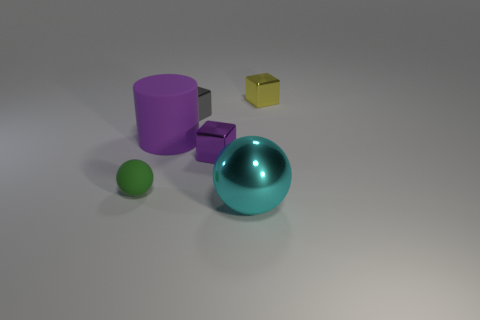Are there any other things that are the same shape as the big purple object?
Offer a terse response. No. What number of cylinders are green matte objects or metallic objects?
Keep it short and to the point. 0. Do the purple thing on the right side of the big purple cylinder and the metal block behind the small gray shiny cube have the same size?
Make the answer very short. Yes. What material is the sphere on the left side of the small cube in front of the large rubber object?
Ensure brevity in your answer.  Rubber. Is the number of shiny spheres that are left of the purple cylinder less than the number of tiny brown cubes?
Your answer should be very brief. No. The gray object that is the same material as the large sphere is what shape?
Give a very brief answer. Cube. What number of other things are there of the same shape as the gray object?
Offer a terse response. 2. What number of yellow things are either big matte cylinders or tiny cubes?
Keep it short and to the point. 1. Is the tiny gray object the same shape as the cyan object?
Give a very brief answer. No. Are there any metallic cubes that are behind the ball left of the cyan object?
Give a very brief answer. Yes. 